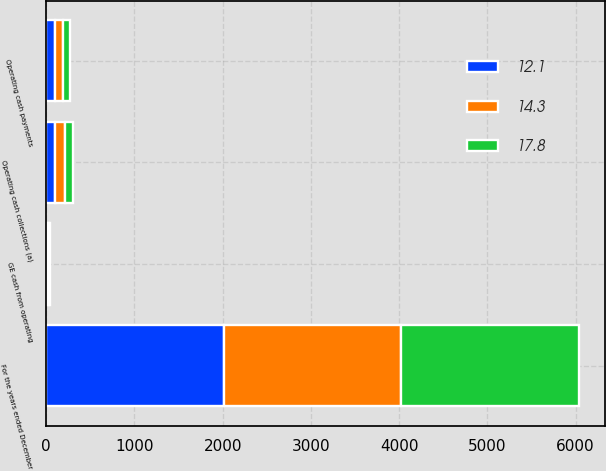<chart> <loc_0><loc_0><loc_500><loc_500><stacked_bar_chart><ecel><fcel>For the years ended December<fcel>Operating cash collections (a)<fcel>Operating cash payments<fcel>GE cash from operating<nl><fcel>12.1<fcel>2013<fcel>104.8<fcel>96.5<fcel>14.3<nl><fcel>14.3<fcel>2012<fcel>105.4<fcel>94<fcel>17.8<nl><fcel>17.8<fcel>2011<fcel>93.6<fcel>81.5<fcel>12.1<nl></chart> 